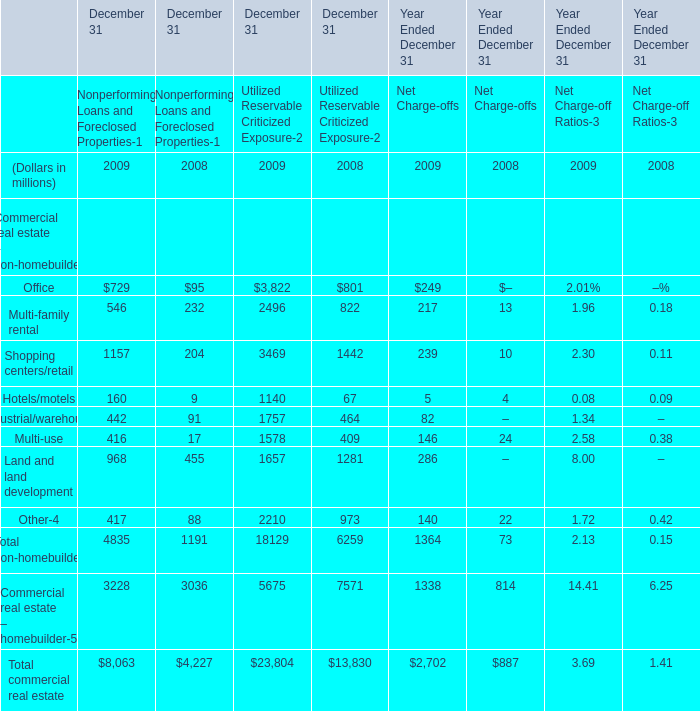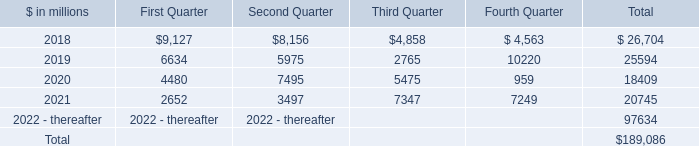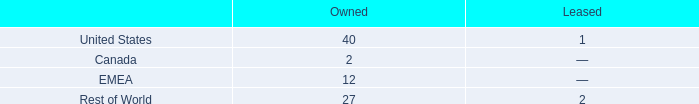What's the average of Office and Multi-family rental in 2009? (in million) 
Computations: ((((729 + 3822) + 546) + 2496) / 2)
Answer: 3796.5. 